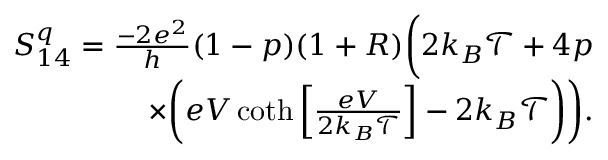<formula> <loc_0><loc_0><loc_500><loc_500>\begin{array} { r } { S _ { 1 4 } ^ { q } = \frac { - 2 e ^ { 2 } } { h } ( 1 - p ) ( 1 + R ) \left ( 2 k _ { B } \mathcal { T } + 4 p } \\ { \times \left ( e V \coth \left [ \frac { e V } { 2 k _ { B } \mathcal { T } } \right ] - 2 k _ { B } \mathcal { T } \right ) \right ) . } \end{array}</formula> 